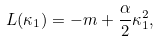<formula> <loc_0><loc_0><loc_500><loc_500>L ( \kappa _ { 1 } ) = - m + \frac { \alpha } { 2 } \kappa _ { 1 } ^ { 2 } ,</formula> 